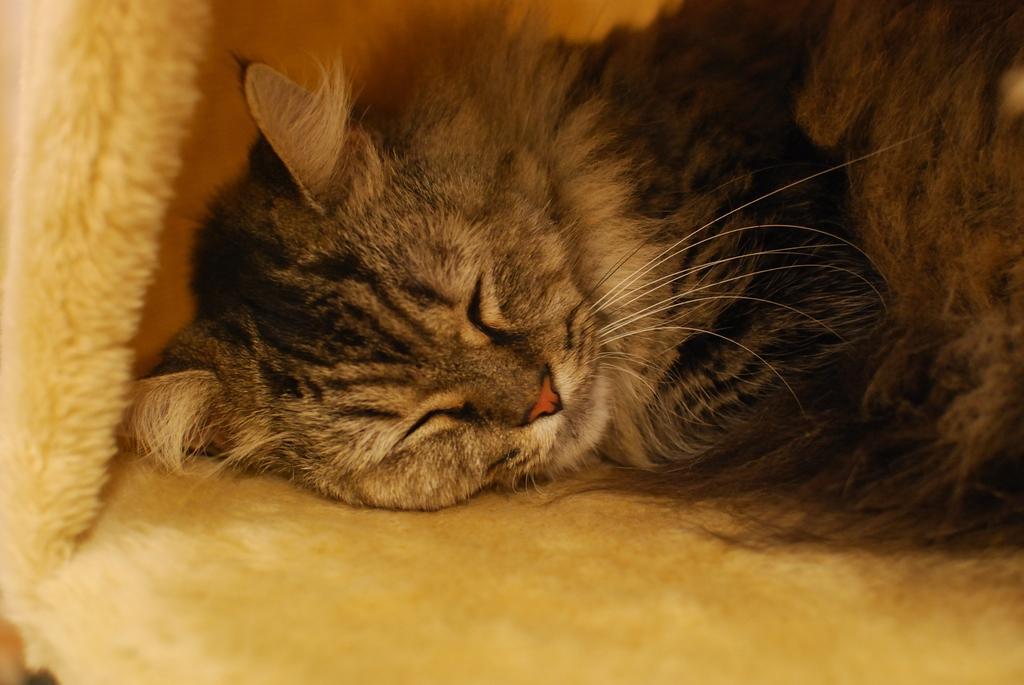Please provide a concise description of this image. There is a cat in black and white color combination. Which is sleeping on yellow color cloth. 